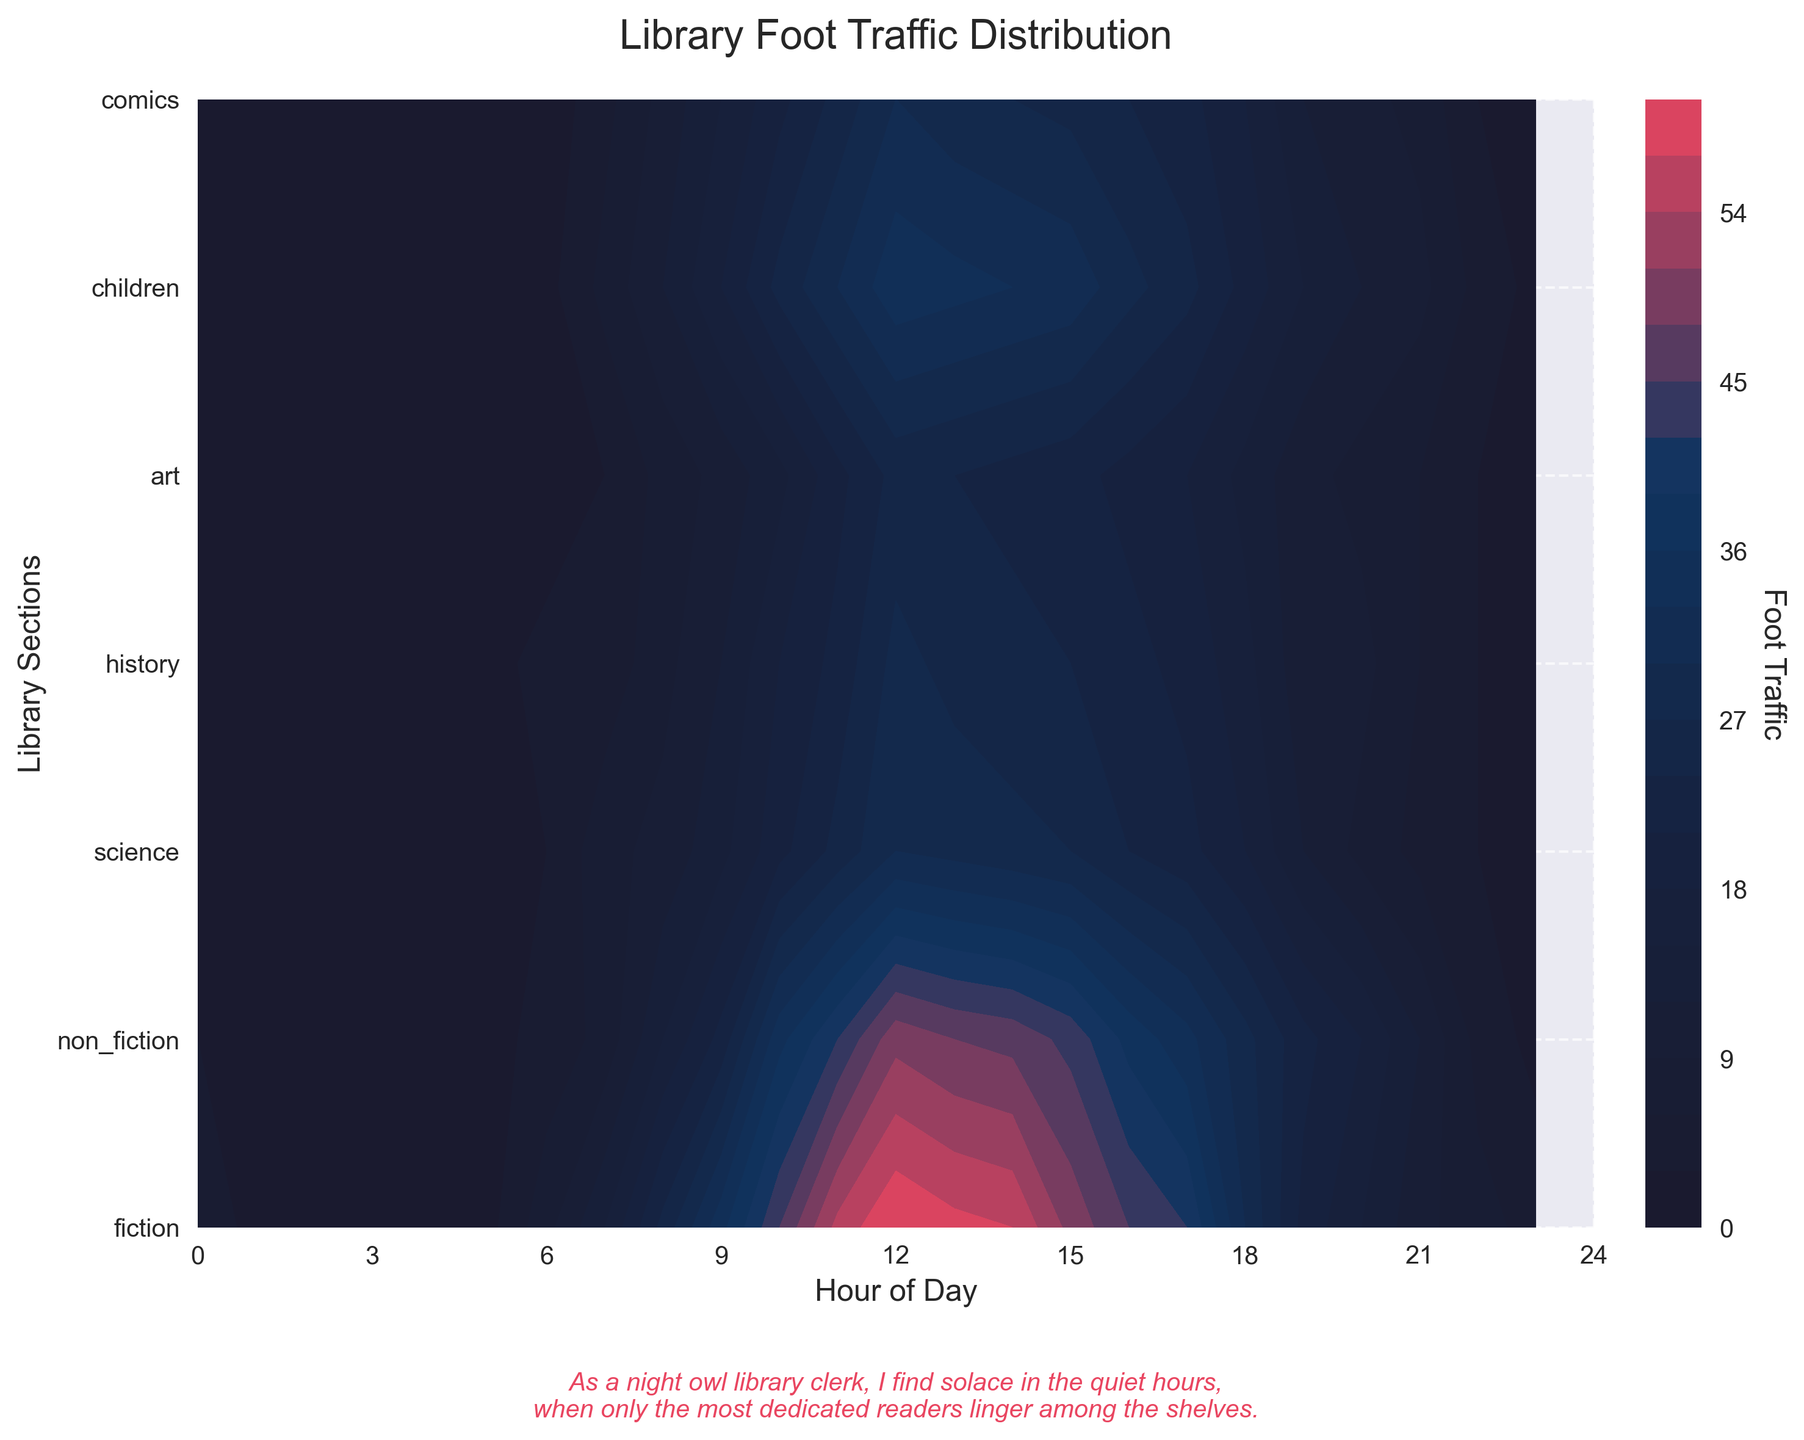What's the title of the figure? The title of the figure is given at the top center of the plot.
Answer: Library Foot Traffic Distribution What are the labels for the x and y axes? The labels for the x and y axes can be found along the respective axes. The x-axis is labeled "Hour of Day" and the y-axis is labeled "Library Sections".
Answer: Hour of Day, Library Sections How does the foot traffic in the children's section at 12am (midnight) compare to the same section at 12pm (noon)? By examining the color gradient and contours at 12am and 12pm for the children's section, we can see that the foot traffic is almost negligible at 12am, while it's very high at 12pm.
Answer: Much higher at noon Which genre section has the highest foot traffic during peak hours? By referring to the darker shades of the contour plot, the fiction section shows the highest foot traffic during peak hours.
Answer: Fiction During what time period does the comic section see significant foot traffic? By following the colored contours, particularly looking for lighter shades in the comic section, there's significant foot traffic around 10am to 3pm.
Answer: 10am to 3pm What seems to be the quietest time for the history section? By examining the contours, the history section shows darker colors indicating lower foot traffic from 1am to 4am.
Answer: 1am to 4am What's the trend in foot traffic for the science section from 9am to 6pm? Observing the contour colors from 9am to 6pm, foot traffic increases steadily, peaks around midday, and then gradually decreases.
Answer: Increases till midday, then decreases Between which hours is the overall foot traffic in the library most evenly distributed across genres? Identifying the overlaps and uniformly shaded regions, foot traffic across genres is most evenly distributed around 10am to 2pm.
Answer: 10am to 2pm Which section experiences the earliest increase in foot traffic in the morning? The contours show the fiction section starts experiencing increased foot traffic earlier in the morning compared to others.
Answer: Fiction 